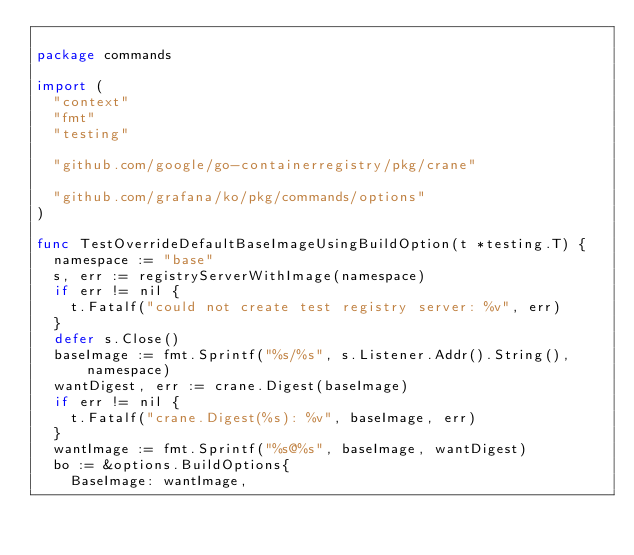<code> <loc_0><loc_0><loc_500><loc_500><_Go_>
package commands

import (
	"context"
	"fmt"
	"testing"

	"github.com/google/go-containerregistry/pkg/crane"

	"github.com/grafana/ko/pkg/commands/options"
)

func TestOverrideDefaultBaseImageUsingBuildOption(t *testing.T) {
	namespace := "base"
	s, err := registryServerWithImage(namespace)
	if err != nil {
		t.Fatalf("could not create test registry server: %v", err)
	}
	defer s.Close()
	baseImage := fmt.Sprintf("%s/%s", s.Listener.Addr().String(), namespace)
	wantDigest, err := crane.Digest(baseImage)
	if err != nil {
		t.Fatalf("crane.Digest(%s): %v", baseImage, err)
	}
	wantImage := fmt.Sprintf("%s@%s", baseImage, wantDigest)
	bo := &options.BuildOptions{
		BaseImage: wantImage,</code> 